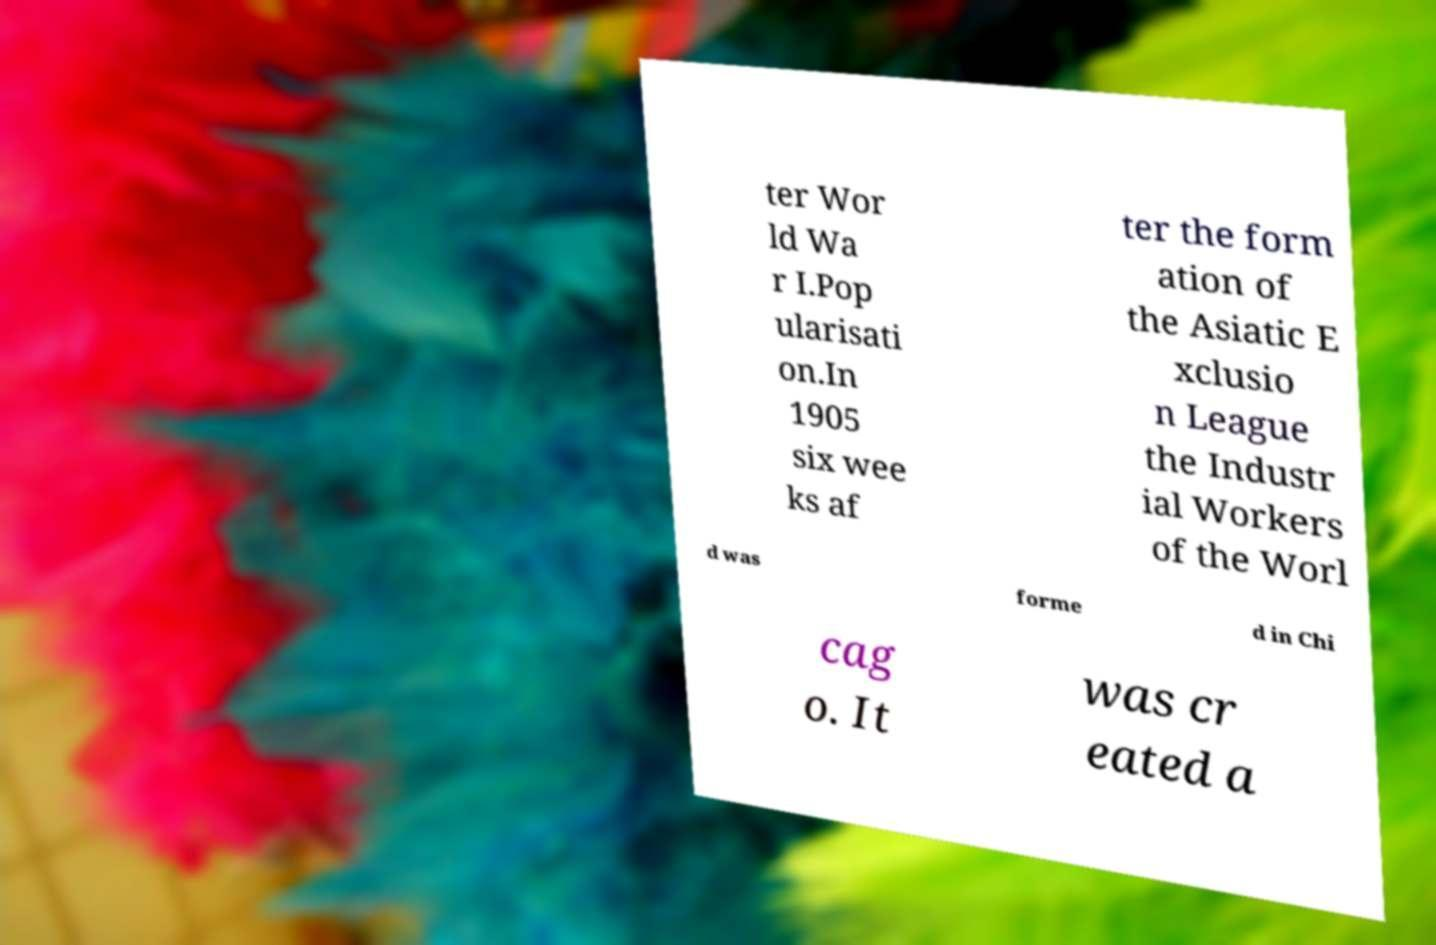There's text embedded in this image that I need extracted. Can you transcribe it verbatim? ter Wor ld Wa r I.Pop ularisati on.In 1905 six wee ks af ter the form ation of the Asiatic E xclusio n League the Industr ial Workers of the Worl d was forme d in Chi cag o. It was cr eated a 